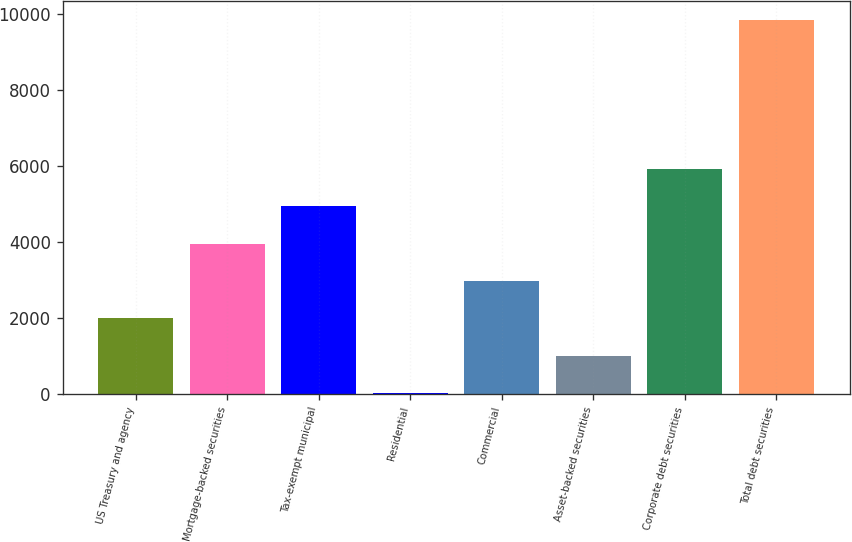<chart> <loc_0><loc_0><loc_500><loc_500><bar_chart><fcel>US Treasury and agency<fcel>Mortgage-backed securities<fcel>Tax-exempt municipal<fcel>Residential<fcel>Commercial<fcel>Asset-backed securities<fcel>Corporate debt securities<fcel>Total debt securities<nl><fcel>1996.6<fcel>3959.2<fcel>4940.5<fcel>34<fcel>2977.9<fcel>1015.3<fcel>5921.8<fcel>9847<nl></chart> 